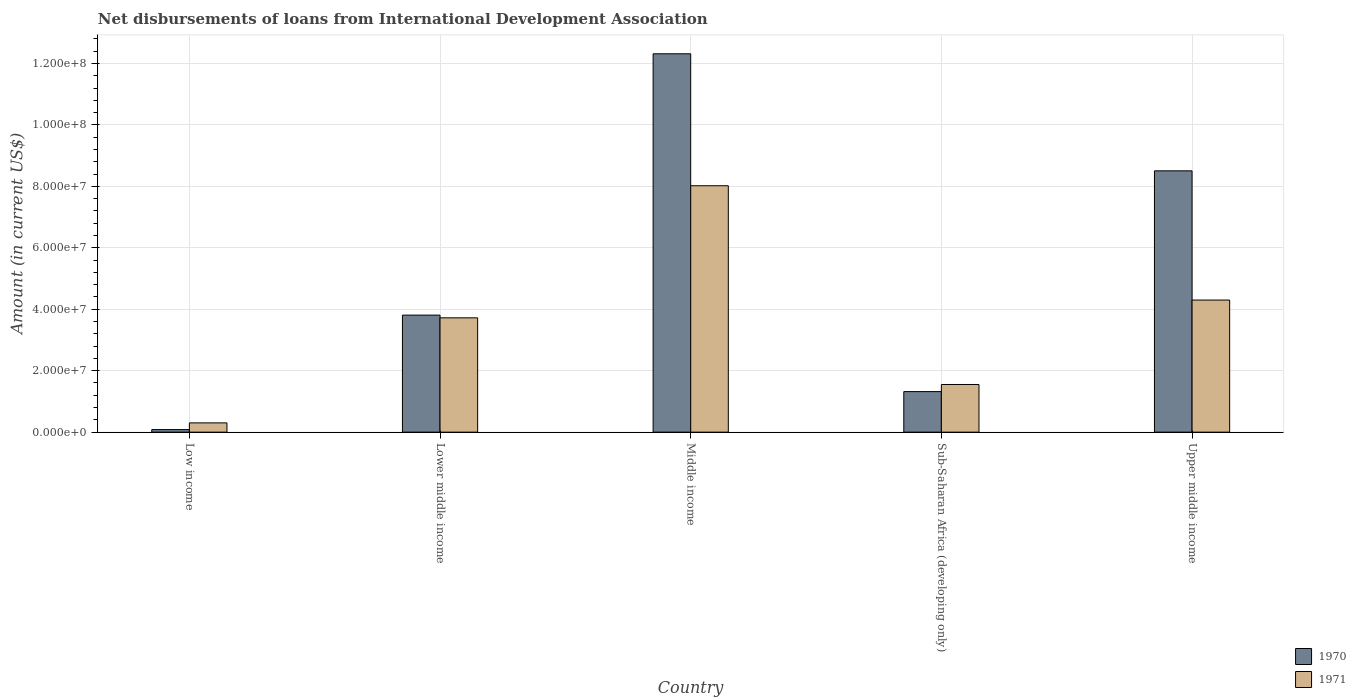Are the number of bars per tick equal to the number of legend labels?
Your response must be concise. Yes. Are the number of bars on each tick of the X-axis equal?
Provide a short and direct response. Yes. How many bars are there on the 3rd tick from the right?
Provide a succinct answer. 2. What is the amount of loans disbursed in 1971 in Middle income?
Your answer should be very brief. 8.02e+07. Across all countries, what is the maximum amount of loans disbursed in 1971?
Your answer should be compact. 8.02e+07. Across all countries, what is the minimum amount of loans disbursed in 1970?
Your response must be concise. 8.35e+05. In which country was the amount of loans disbursed in 1970 minimum?
Your answer should be compact. Low income. What is the total amount of loans disbursed in 1970 in the graph?
Offer a very short reply. 2.60e+08. What is the difference between the amount of loans disbursed in 1971 in Low income and that in Middle income?
Offer a very short reply. -7.72e+07. What is the difference between the amount of loans disbursed in 1971 in Low income and the amount of loans disbursed in 1970 in Sub-Saharan Africa (developing only)?
Offer a terse response. -1.02e+07. What is the average amount of loans disbursed in 1971 per country?
Ensure brevity in your answer.  3.58e+07. What is the difference between the amount of loans disbursed of/in 1970 and amount of loans disbursed of/in 1971 in Low income?
Your response must be concise. -2.18e+06. In how many countries, is the amount of loans disbursed in 1971 greater than 64000000 US$?
Ensure brevity in your answer.  1. What is the ratio of the amount of loans disbursed in 1971 in Lower middle income to that in Sub-Saharan Africa (developing only)?
Provide a short and direct response. 2.4. Is the difference between the amount of loans disbursed in 1970 in Low income and Upper middle income greater than the difference between the amount of loans disbursed in 1971 in Low income and Upper middle income?
Your answer should be very brief. No. What is the difference between the highest and the second highest amount of loans disbursed in 1971?
Your answer should be very brief. 4.30e+07. What is the difference between the highest and the lowest amount of loans disbursed in 1970?
Make the answer very short. 1.22e+08. How many bars are there?
Ensure brevity in your answer.  10. Are all the bars in the graph horizontal?
Make the answer very short. No. What is the difference between two consecutive major ticks on the Y-axis?
Offer a terse response. 2.00e+07. Are the values on the major ticks of Y-axis written in scientific E-notation?
Offer a very short reply. Yes. Does the graph contain any zero values?
Offer a very short reply. No. How many legend labels are there?
Your answer should be very brief. 2. How are the legend labels stacked?
Offer a very short reply. Vertical. What is the title of the graph?
Give a very brief answer. Net disbursements of loans from International Development Association. Does "1967" appear as one of the legend labels in the graph?
Your answer should be very brief. No. What is the label or title of the X-axis?
Offer a very short reply. Country. What is the Amount (in current US$) of 1970 in Low income?
Keep it short and to the point. 8.35e+05. What is the Amount (in current US$) in 1971 in Low income?
Offer a very short reply. 3.02e+06. What is the Amount (in current US$) in 1970 in Lower middle income?
Give a very brief answer. 3.81e+07. What is the Amount (in current US$) in 1971 in Lower middle income?
Provide a succinct answer. 3.72e+07. What is the Amount (in current US$) of 1970 in Middle income?
Offer a very short reply. 1.23e+08. What is the Amount (in current US$) in 1971 in Middle income?
Offer a terse response. 8.02e+07. What is the Amount (in current US$) of 1970 in Sub-Saharan Africa (developing only)?
Offer a very short reply. 1.32e+07. What is the Amount (in current US$) in 1971 in Sub-Saharan Africa (developing only)?
Your answer should be very brief. 1.55e+07. What is the Amount (in current US$) of 1970 in Upper middle income?
Keep it short and to the point. 8.51e+07. What is the Amount (in current US$) of 1971 in Upper middle income?
Make the answer very short. 4.30e+07. Across all countries, what is the maximum Amount (in current US$) of 1970?
Make the answer very short. 1.23e+08. Across all countries, what is the maximum Amount (in current US$) in 1971?
Give a very brief answer. 8.02e+07. Across all countries, what is the minimum Amount (in current US$) in 1970?
Offer a very short reply. 8.35e+05. Across all countries, what is the minimum Amount (in current US$) in 1971?
Make the answer very short. 3.02e+06. What is the total Amount (in current US$) of 1970 in the graph?
Provide a succinct answer. 2.60e+08. What is the total Amount (in current US$) in 1971 in the graph?
Provide a short and direct response. 1.79e+08. What is the difference between the Amount (in current US$) in 1970 in Low income and that in Lower middle income?
Provide a short and direct response. -3.73e+07. What is the difference between the Amount (in current US$) of 1971 in Low income and that in Lower middle income?
Provide a short and direct response. -3.42e+07. What is the difference between the Amount (in current US$) of 1970 in Low income and that in Middle income?
Keep it short and to the point. -1.22e+08. What is the difference between the Amount (in current US$) of 1971 in Low income and that in Middle income?
Keep it short and to the point. -7.72e+07. What is the difference between the Amount (in current US$) of 1970 in Low income and that in Sub-Saharan Africa (developing only)?
Provide a succinct answer. -1.24e+07. What is the difference between the Amount (in current US$) of 1971 in Low income and that in Sub-Saharan Africa (developing only)?
Your response must be concise. -1.25e+07. What is the difference between the Amount (in current US$) in 1970 in Low income and that in Upper middle income?
Provide a short and direct response. -8.42e+07. What is the difference between the Amount (in current US$) of 1971 in Low income and that in Upper middle income?
Ensure brevity in your answer.  -4.00e+07. What is the difference between the Amount (in current US$) in 1970 in Lower middle income and that in Middle income?
Offer a very short reply. -8.51e+07. What is the difference between the Amount (in current US$) in 1971 in Lower middle income and that in Middle income?
Offer a terse response. -4.30e+07. What is the difference between the Amount (in current US$) of 1970 in Lower middle income and that in Sub-Saharan Africa (developing only)?
Make the answer very short. 2.49e+07. What is the difference between the Amount (in current US$) in 1971 in Lower middle income and that in Sub-Saharan Africa (developing only)?
Offer a terse response. 2.17e+07. What is the difference between the Amount (in current US$) of 1970 in Lower middle income and that in Upper middle income?
Provide a short and direct response. -4.70e+07. What is the difference between the Amount (in current US$) in 1971 in Lower middle income and that in Upper middle income?
Keep it short and to the point. -5.79e+06. What is the difference between the Amount (in current US$) of 1970 in Middle income and that in Sub-Saharan Africa (developing only)?
Provide a succinct answer. 1.10e+08. What is the difference between the Amount (in current US$) in 1971 in Middle income and that in Sub-Saharan Africa (developing only)?
Ensure brevity in your answer.  6.47e+07. What is the difference between the Amount (in current US$) of 1970 in Middle income and that in Upper middle income?
Your answer should be compact. 3.81e+07. What is the difference between the Amount (in current US$) of 1971 in Middle income and that in Upper middle income?
Your response must be concise. 3.72e+07. What is the difference between the Amount (in current US$) of 1970 in Sub-Saharan Africa (developing only) and that in Upper middle income?
Offer a terse response. -7.19e+07. What is the difference between the Amount (in current US$) of 1971 in Sub-Saharan Africa (developing only) and that in Upper middle income?
Offer a very short reply. -2.75e+07. What is the difference between the Amount (in current US$) of 1970 in Low income and the Amount (in current US$) of 1971 in Lower middle income?
Offer a terse response. -3.64e+07. What is the difference between the Amount (in current US$) in 1970 in Low income and the Amount (in current US$) in 1971 in Middle income?
Give a very brief answer. -7.94e+07. What is the difference between the Amount (in current US$) in 1970 in Low income and the Amount (in current US$) in 1971 in Sub-Saharan Africa (developing only)?
Keep it short and to the point. -1.47e+07. What is the difference between the Amount (in current US$) in 1970 in Low income and the Amount (in current US$) in 1971 in Upper middle income?
Keep it short and to the point. -4.22e+07. What is the difference between the Amount (in current US$) in 1970 in Lower middle income and the Amount (in current US$) in 1971 in Middle income?
Ensure brevity in your answer.  -4.21e+07. What is the difference between the Amount (in current US$) of 1970 in Lower middle income and the Amount (in current US$) of 1971 in Sub-Saharan Africa (developing only)?
Ensure brevity in your answer.  2.26e+07. What is the difference between the Amount (in current US$) in 1970 in Lower middle income and the Amount (in current US$) in 1971 in Upper middle income?
Give a very brief answer. -4.90e+06. What is the difference between the Amount (in current US$) of 1970 in Middle income and the Amount (in current US$) of 1971 in Sub-Saharan Africa (developing only)?
Offer a very short reply. 1.08e+08. What is the difference between the Amount (in current US$) in 1970 in Middle income and the Amount (in current US$) in 1971 in Upper middle income?
Your response must be concise. 8.02e+07. What is the difference between the Amount (in current US$) in 1970 in Sub-Saharan Africa (developing only) and the Amount (in current US$) in 1971 in Upper middle income?
Give a very brief answer. -2.98e+07. What is the average Amount (in current US$) of 1970 per country?
Offer a very short reply. 5.21e+07. What is the average Amount (in current US$) in 1971 per country?
Make the answer very short. 3.58e+07. What is the difference between the Amount (in current US$) of 1970 and Amount (in current US$) of 1971 in Low income?
Your response must be concise. -2.18e+06. What is the difference between the Amount (in current US$) of 1970 and Amount (in current US$) of 1971 in Lower middle income?
Give a very brief answer. 8.88e+05. What is the difference between the Amount (in current US$) of 1970 and Amount (in current US$) of 1971 in Middle income?
Make the answer very short. 4.30e+07. What is the difference between the Amount (in current US$) of 1970 and Amount (in current US$) of 1971 in Sub-Saharan Africa (developing only)?
Provide a succinct answer. -2.31e+06. What is the difference between the Amount (in current US$) of 1970 and Amount (in current US$) of 1971 in Upper middle income?
Your response must be concise. 4.21e+07. What is the ratio of the Amount (in current US$) in 1970 in Low income to that in Lower middle income?
Your answer should be very brief. 0.02. What is the ratio of the Amount (in current US$) of 1971 in Low income to that in Lower middle income?
Your answer should be compact. 0.08. What is the ratio of the Amount (in current US$) in 1970 in Low income to that in Middle income?
Provide a short and direct response. 0.01. What is the ratio of the Amount (in current US$) of 1971 in Low income to that in Middle income?
Give a very brief answer. 0.04. What is the ratio of the Amount (in current US$) of 1970 in Low income to that in Sub-Saharan Africa (developing only)?
Your response must be concise. 0.06. What is the ratio of the Amount (in current US$) in 1971 in Low income to that in Sub-Saharan Africa (developing only)?
Your response must be concise. 0.19. What is the ratio of the Amount (in current US$) in 1970 in Low income to that in Upper middle income?
Your response must be concise. 0.01. What is the ratio of the Amount (in current US$) of 1971 in Low income to that in Upper middle income?
Provide a short and direct response. 0.07. What is the ratio of the Amount (in current US$) in 1970 in Lower middle income to that in Middle income?
Give a very brief answer. 0.31. What is the ratio of the Amount (in current US$) of 1971 in Lower middle income to that in Middle income?
Provide a short and direct response. 0.46. What is the ratio of the Amount (in current US$) of 1970 in Lower middle income to that in Sub-Saharan Africa (developing only)?
Offer a terse response. 2.89. What is the ratio of the Amount (in current US$) in 1971 in Lower middle income to that in Sub-Saharan Africa (developing only)?
Give a very brief answer. 2.4. What is the ratio of the Amount (in current US$) in 1970 in Lower middle income to that in Upper middle income?
Your answer should be compact. 0.45. What is the ratio of the Amount (in current US$) in 1971 in Lower middle income to that in Upper middle income?
Offer a very short reply. 0.87. What is the ratio of the Amount (in current US$) of 1970 in Middle income to that in Sub-Saharan Africa (developing only)?
Make the answer very short. 9.33. What is the ratio of the Amount (in current US$) in 1971 in Middle income to that in Sub-Saharan Africa (developing only)?
Give a very brief answer. 5.17. What is the ratio of the Amount (in current US$) in 1970 in Middle income to that in Upper middle income?
Give a very brief answer. 1.45. What is the ratio of the Amount (in current US$) of 1971 in Middle income to that in Upper middle income?
Give a very brief answer. 1.87. What is the ratio of the Amount (in current US$) in 1970 in Sub-Saharan Africa (developing only) to that in Upper middle income?
Keep it short and to the point. 0.16. What is the ratio of the Amount (in current US$) of 1971 in Sub-Saharan Africa (developing only) to that in Upper middle income?
Your answer should be very brief. 0.36. What is the difference between the highest and the second highest Amount (in current US$) of 1970?
Your answer should be compact. 3.81e+07. What is the difference between the highest and the second highest Amount (in current US$) in 1971?
Make the answer very short. 3.72e+07. What is the difference between the highest and the lowest Amount (in current US$) in 1970?
Offer a very short reply. 1.22e+08. What is the difference between the highest and the lowest Amount (in current US$) of 1971?
Give a very brief answer. 7.72e+07. 